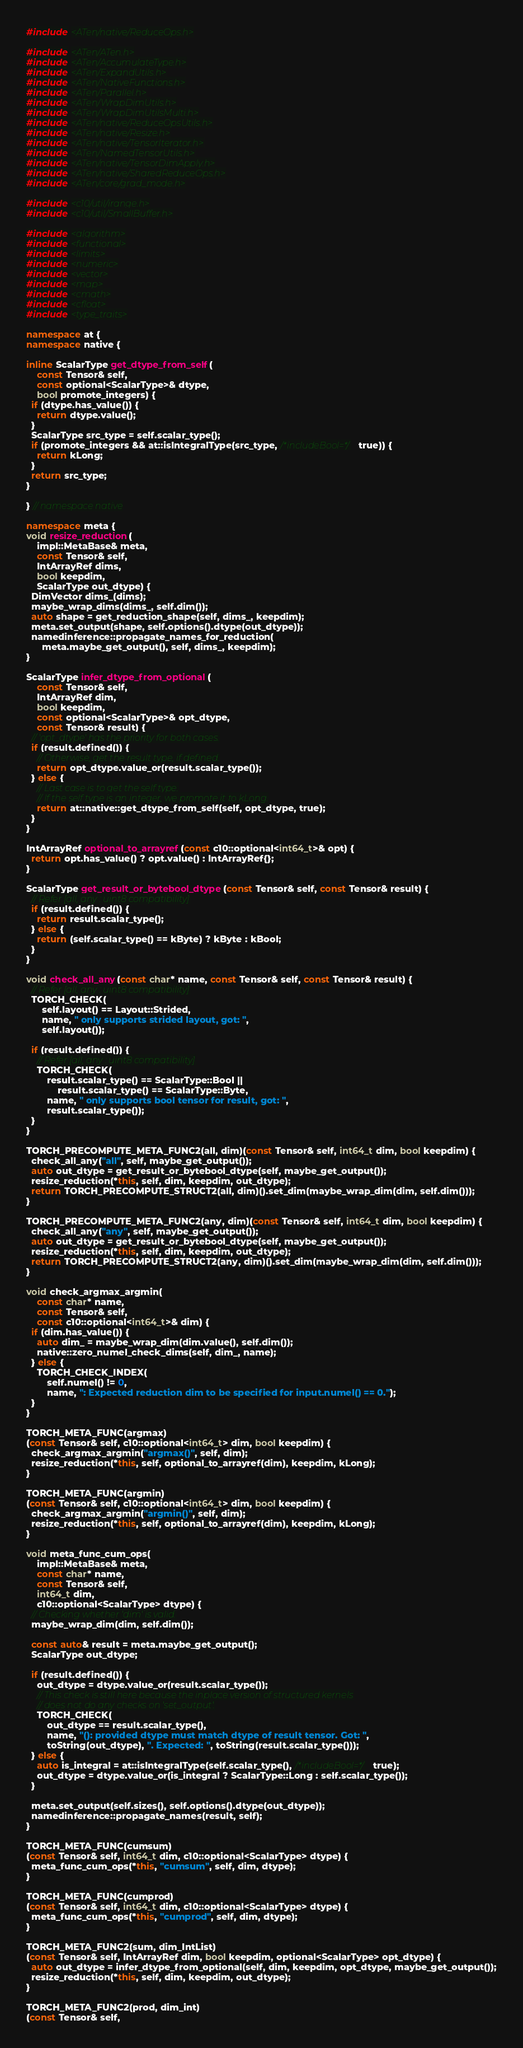<code> <loc_0><loc_0><loc_500><loc_500><_C++_>#include <ATen/native/ReduceOps.h>

#include <ATen/ATen.h>
#include <ATen/AccumulateType.h>
#include <ATen/ExpandUtils.h>
#include <ATen/NativeFunctions.h>
#include <ATen/Parallel.h>
#include <ATen/WrapDimUtils.h>
#include <ATen/WrapDimUtilsMulti.h>
#include <ATen/native/ReduceOpsUtils.h>
#include <ATen/native/Resize.h>
#include <ATen/native/TensorIterator.h>
#include <ATen/NamedTensorUtils.h>
#include <ATen/native/TensorDimApply.h>
#include <ATen/native/SharedReduceOps.h>
#include <ATen/core/grad_mode.h>

#include <c10/util/irange.h>
#include <c10/util/SmallBuffer.h>

#include <algorithm>
#include <functional>
#include <limits>
#include <numeric>
#include <vector>
#include <map>
#include <cmath>
#include <cfloat>
#include <type_traits>

namespace at {
namespace native {

inline ScalarType get_dtype_from_self(
    const Tensor& self,
    const optional<ScalarType>& dtype,
    bool promote_integers) {
  if (dtype.has_value()) {
    return dtype.value();
  }
  ScalarType src_type = self.scalar_type();
  if (promote_integers && at::isIntegralType(src_type, /*includeBool=*/true)) {
    return kLong;
  }
  return src_type;
}

} // namespace native

namespace meta {
void resize_reduction(
    impl::MetaBase& meta,
    const Tensor& self,
    IntArrayRef dims,
    bool keepdim,
    ScalarType out_dtype) {
  DimVector dims_(dims);
  maybe_wrap_dims(dims_, self.dim());
  auto shape = get_reduction_shape(self, dims_, keepdim);
  meta.set_output(shape, self.options().dtype(out_dtype));
  namedinference::propagate_names_for_reduction(
      meta.maybe_get_output(), self, dims_, keepdim);
}

ScalarType infer_dtype_from_optional(
    const Tensor& self,
    IntArrayRef dim,
    bool keepdim,
    const optional<ScalarType>& opt_dtype,
    const Tensor& result) {
  // 'opt_dtype' has the priority for both cases.
  if (result.defined()) {
    // Otherwise, get the result type, if defined.
    return opt_dtype.value_or(result.scalar_type());
  } else {
    // Last case is to get the self type.
    // If the self type is an integer, we promote it to kLong.
    return at::native::get_dtype_from_self(self, opt_dtype, true);
  }
}

IntArrayRef optional_to_arrayref(const c10::optional<int64_t>& opt) {
  return opt.has_value() ? opt.value() : IntArrayRef{};
}

ScalarType get_result_or_bytebool_dtype(const Tensor& self, const Tensor& result) {
  // Refer [all, any : uint8 compatibility]
  if (result.defined()) {
    return result.scalar_type();
  } else {
    return (self.scalar_type() == kByte) ? kByte : kBool;
  }
}

void check_all_any(const char* name, const Tensor& self, const Tensor& result) {
  // Refer [all, any : uint8 compatibility]
  TORCH_CHECK(
      self.layout() == Layout::Strided,
      name, " only supports strided layout, got: ",
      self.layout());

  if (result.defined()) {
    // Refer [all, any : uint8 compatibility]
    TORCH_CHECK(
        result.scalar_type() == ScalarType::Bool ||
            result.scalar_type() == ScalarType::Byte,
        name, " only supports bool tensor for result, got: ",
        result.scalar_type());
  }
}

TORCH_PRECOMPUTE_META_FUNC2(all, dim)(const Tensor& self, int64_t dim, bool keepdim) {
  check_all_any("all", self, maybe_get_output());
  auto out_dtype = get_result_or_bytebool_dtype(self, maybe_get_output());
  resize_reduction(*this, self, dim, keepdim, out_dtype);
  return TORCH_PRECOMPUTE_STRUCT2(all, dim)().set_dim(maybe_wrap_dim(dim, self.dim()));
}

TORCH_PRECOMPUTE_META_FUNC2(any, dim)(const Tensor& self, int64_t dim, bool keepdim) {
  check_all_any("any", self, maybe_get_output());
  auto out_dtype = get_result_or_bytebool_dtype(self, maybe_get_output());
  resize_reduction(*this, self, dim, keepdim, out_dtype);
  return TORCH_PRECOMPUTE_STRUCT2(any, dim)().set_dim(maybe_wrap_dim(dim, self.dim()));
}

void check_argmax_argmin(
    const char* name,
    const Tensor& self,
    const c10::optional<int64_t>& dim) {
  if (dim.has_value()) {
    auto dim_ = maybe_wrap_dim(dim.value(), self.dim());
    native::zero_numel_check_dims(self, dim_, name);
  } else {
    TORCH_CHECK_INDEX(
        self.numel() != 0,
        name, ": Expected reduction dim to be specified for input.numel() == 0.");
  }
}

TORCH_META_FUNC(argmax)
(const Tensor& self, c10::optional<int64_t> dim, bool keepdim) {
  check_argmax_argmin("argmax()", self, dim);
  resize_reduction(*this, self, optional_to_arrayref(dim), keepdim, kLong);
}

TORCH_META_FUNC(argmin)
(const Tensor& self, c10::optional<int64_t> dim, bool keepdim) {
  check_argmax_argmin("argmin()", self, dim);
  resize_reduction(*this, self, optional_to_arrayref(dim), keepdim, kLong);
}

void meta_func_cum_ops(
    impl::MetaBase& meta,
    const char* name,
    const Tensor& self,
    int64_t dim,
    c10::optional<ScalarType> dtype) {
  // Checking whether 'dim' is valid.
  maybe_wrap_dim(dim, self.dim());

  const auto& result = meta.maybe_get_output();
  ScalarType out_dtype;

  if (result.defined()) {
    out_dtype = dtype.value_or(result.scalar_type());
    // This check is still here because the inplace version of structured kernels
    // does not do any checks on 'set_output'.
    TORCH_CHECK(
        out_dtype == result.scalar_type(),
        name, "(): provided dtype must match dtype of result tensor. Got: ",
        toString(out_dtype), ". Expected: ", toString(result.scalar_type()));
  } else {
    auto is_integral = at::isIntegralType(self.scalar_type(), /*includeBool=*/true);
    out_dtype = dtype.value_or(is_integral ? ScalarType::Long : self.scalar_type());
  }

  meta.set_output(self.sizes(), self.options().dtype(out_dtype));
  namedinference::propagate_names(result, self);
}

TORCH_META_FUNC(cumsum)
(const Tensor& self, int64_t dim, c10::optional<ScalarType> dtype) {
  meta_func_cum_ops(*this, "cumsum", self, dim, dtype);
}

TORCH_META_FUNC(cumprod)
(const Tensor& self, int64_t dim, c10::optional<ScalarType> dtype) {
  meta_func_cum_ops(*this, "cumprod", self, dim, dtype);
}

TORCH_META_FUNC2(sum, dim_IntList)
(const Tensor& self, IntArrayRef dim, bool keepdim, optional<ScalarType> opt_dtype) {
  auto out_dtype = infer_dtype_from_optional(self, dim, keepdim, opt_dtype, maybe_get_output());
  resize_reduction(*this, self, dim, keepdim, out_dtype);
}

TORCH_META_FUNC2(prod, dim_int)
(const Tensor& self,</code> 